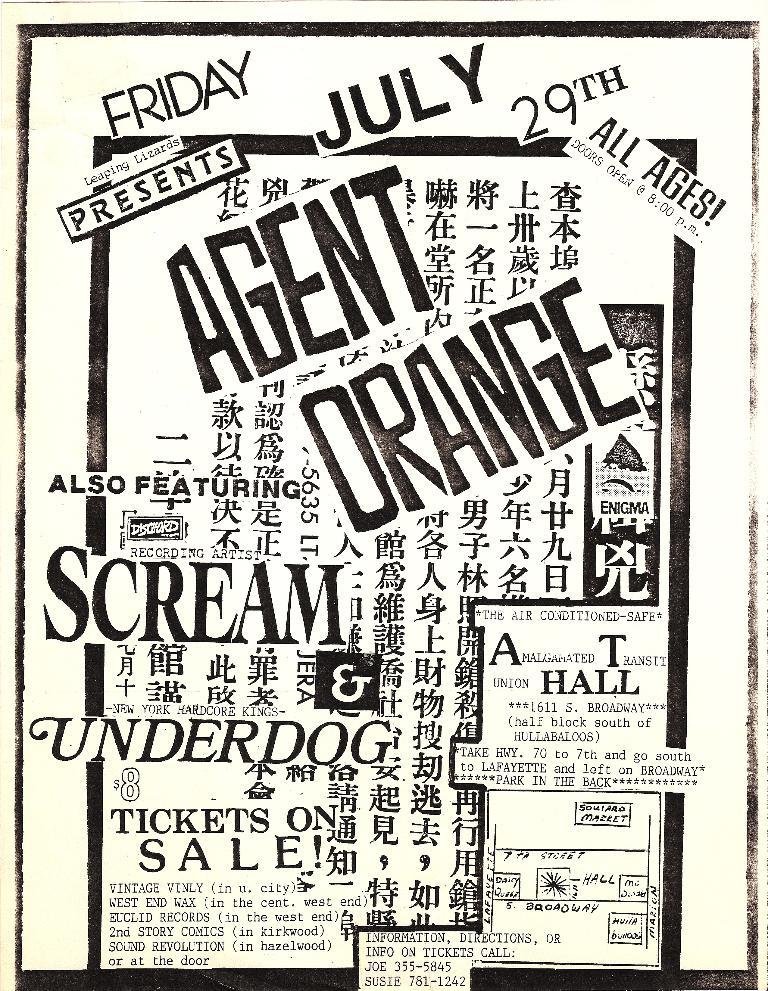What day of the week is this event happening?
Keep it short and to the point. Friday. What is the date of the performance?
Your answer should be compact. July 29. 